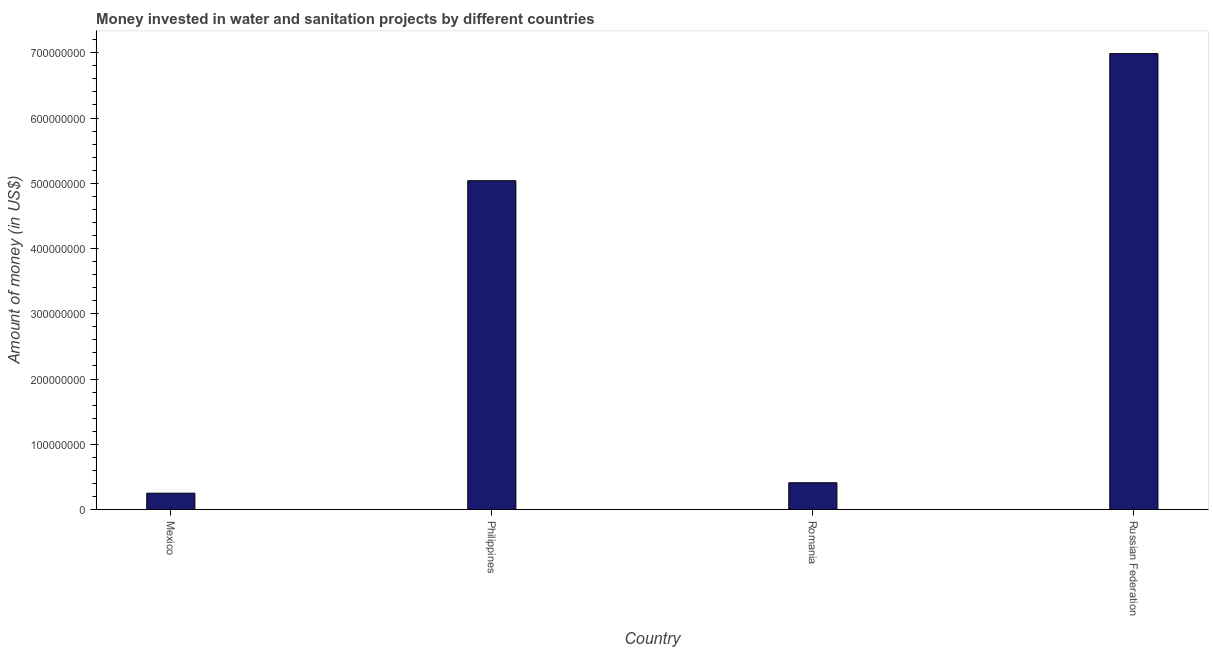Does the graph contain any zero values?
Offer a terse response. No. What is the title of the graph?
Ensure brevity in your answer.  Money invested in water and sanitation projects by different countries. What is the label or title of the X-axis?
Give a very brief answer. Country. What is the label or title of the Y-axis?
Ensure brevity in your answer.  Amount of money (in US$). What is the investment in Philippines?
Offer a very short reply. 5.04e+08. Across all countries, what is the maximum investment?
Provide a succinct answer. 6.99e+08. Across all countries, what is the minimum investment?
Your answer should be very brief. 2.50e+07. In which country was the investment maximum?
Your answer should be very brief. Russian Federation. What is the sum of the investment?
Your answer should be compact. 1.27e+09. What is the difference between the investment in Mexico and Romania?
Ensure brevity in your answer.  -1.60e+07. What is the average investment per country?
Offer a terse response. 3.17e+08. What is the median investment?
Make the answer very short. 2.72e+08. In how many countries, is the investment greater than 660000000 US$?
Make the answer very short. 1. What is the ratio of the investment in Mexico to that in Russian Federation?
Make the answer very short. 0.04. Is the investment in Philippines less than that in Russian Federation?
Provide a short and direct response. Yes. What is the difference between the highest and the second highest investment?
Your answer should be very brief. 1.95e+08. Is the sum of the investment in Mexico and Romania greater than the maximum investment across all countries?
Your response must be concise. No. What is the difference between the highest and the lowest investment?
Your answer should be very brief. 6.74e+08. How many bars are there?
Your answer should be very brief. 4. How many countries are there in the graph?
Your answer should be compact. 4. Are the values on the major ticks of Y-axis written in scientific E-notation?
Your answer should be very brief. No. What is the Amount of money (in US$) in Mexico?
Make the answer very short. 2.50e+07. What is the Amount of money (in US$) in Philippines?
Make the answer very short. 5.04e+08. What is the Amount of money (in US$) of Romania?
Make the answer very short. 4.10e+07. What is the Amount of money (in US$) of Russian Federation?
Offer a very short reply. 6.99e+08. What is the difference between the Amount of money (in US$) in Mexico and Philippines?
Offer a very short reply. -4.79e+08. What is the difference between the Amount of money (in US$) in Mexico and Romania?
Ensure brevity in your answer.  -1.60e+07. What is the difference between the Amount of money (in US$) in Mexico and Russian Federation?
Make the answer very short. -6.74e+08. What is the difference between the Amount of money (in US$) in Philippines and Romania?
Offer a terse response. 4.63e+08. What is the difference between the Amount of money (in US$) in Philippines and Russian Federation?
Give a very brief answer. -1.95e+08. What is the difference between the Amount of money (in US$) in Romania and Russian Federation?
Offer a very short reply. -6.58e+08. What is the ratio of the Amount of money (in US$) in Mexico to that in Philippines?
Keep it short and to the point. 0.05. What is the ratio of the Amount of money (in US$) in Mexico to that in Romania?
Your response must be concise. 0.61. What is the ratio of the Amount of money (in US$) in Mexico to that in Russian Federation?
Provide a succinct answer. 0.04. What is the ratio of the Amount of money (in US$) in Philippines to that in Romania?
Provide a succinct answer. 12.29. What is the ratio of the Amount of money (in US$) in Philippines to that in Russian Federation?
Your answer should be very brief. 0.72. What is the ratio of the Amount of money (in US$) in Romania to that in Russian Federation?
Your answer should be compact. 0.06. 